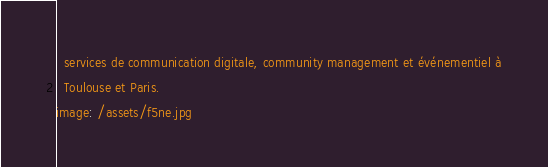Convert code to text. <code><loc_0><loc_0><loc_500><loc_500><_YAML_>  services de communication digitale, community management et événementiel à
  Toulouse et Paris.
image: /assets/f5ne.jpg
</code> 